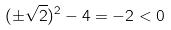<formula> <loc_0><loc_0><loc_500><loc_500>( \pm \sqrt { 2 } ) ^ { 2 } - 4 = - 2 < 0</formula> 